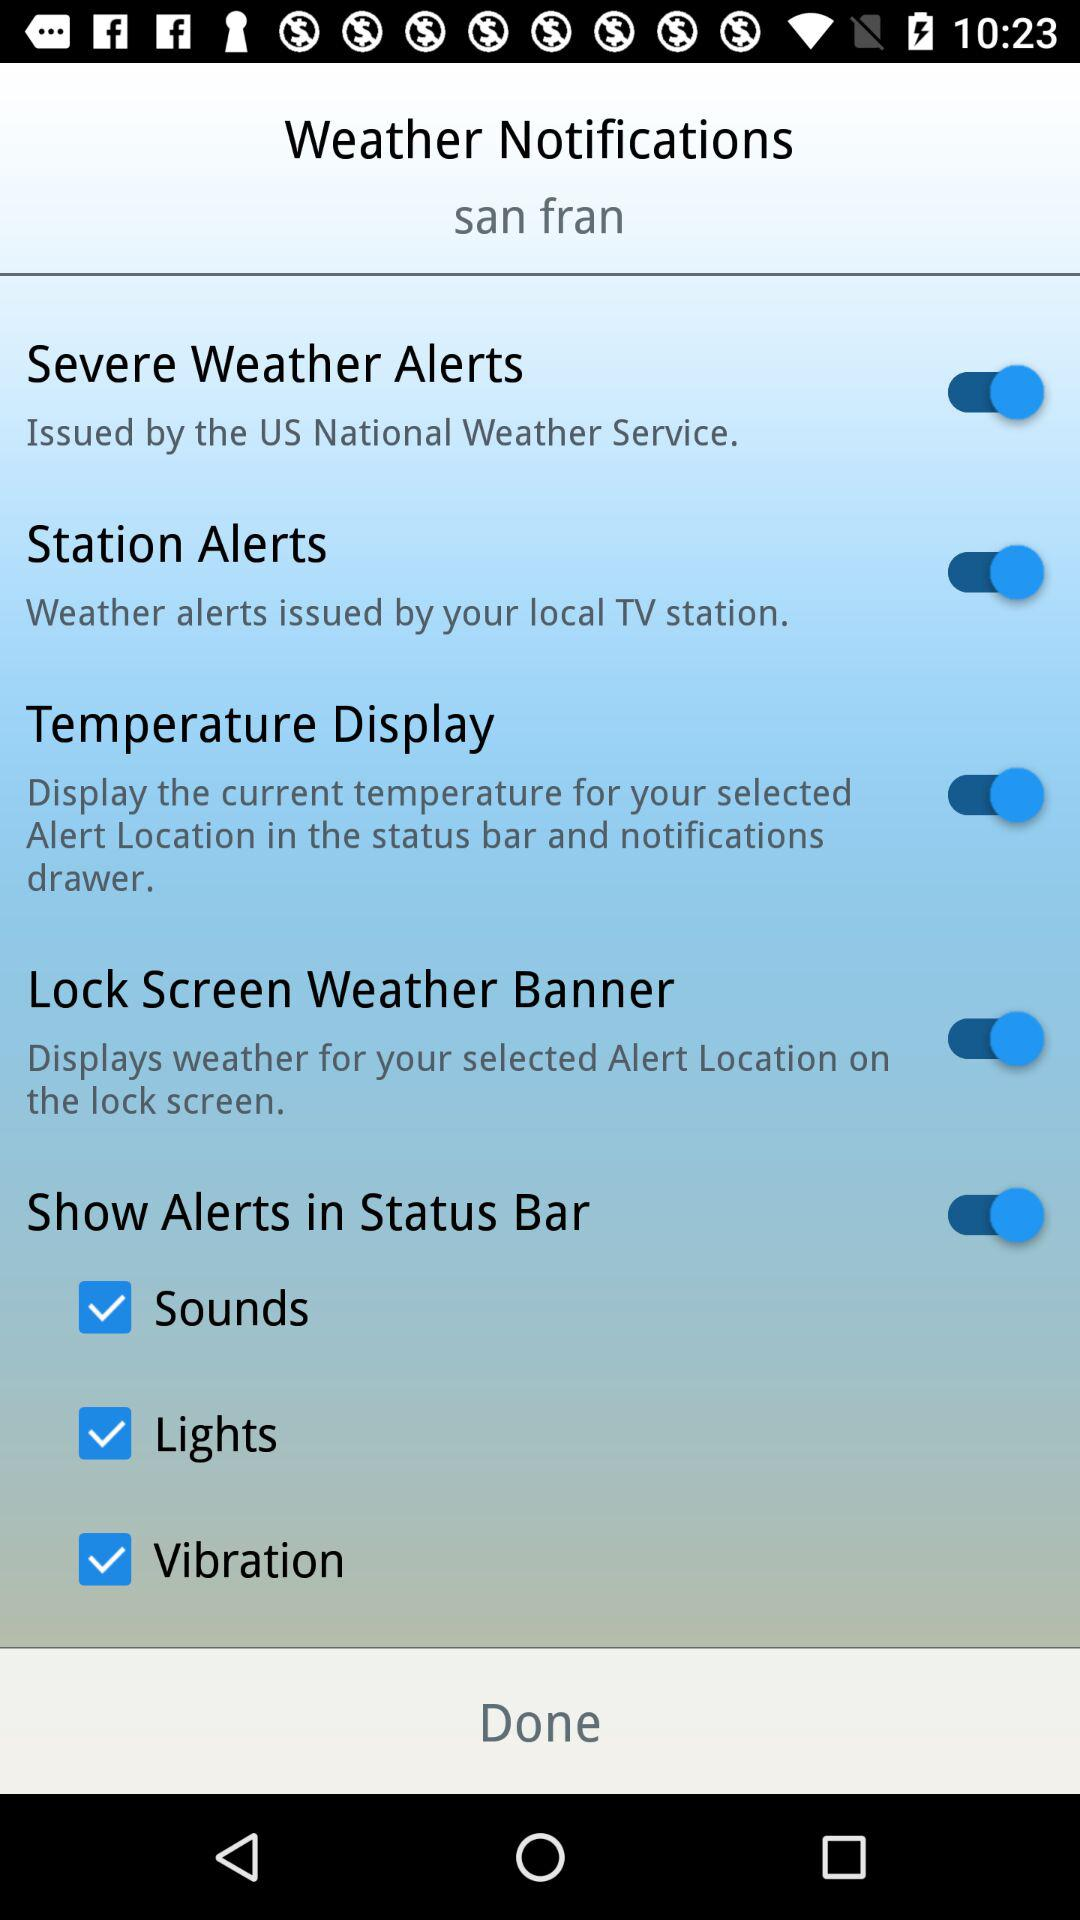How many more checkboxes are there for alerts than for sounds?
Answer the question using a single word or phrase. 2 